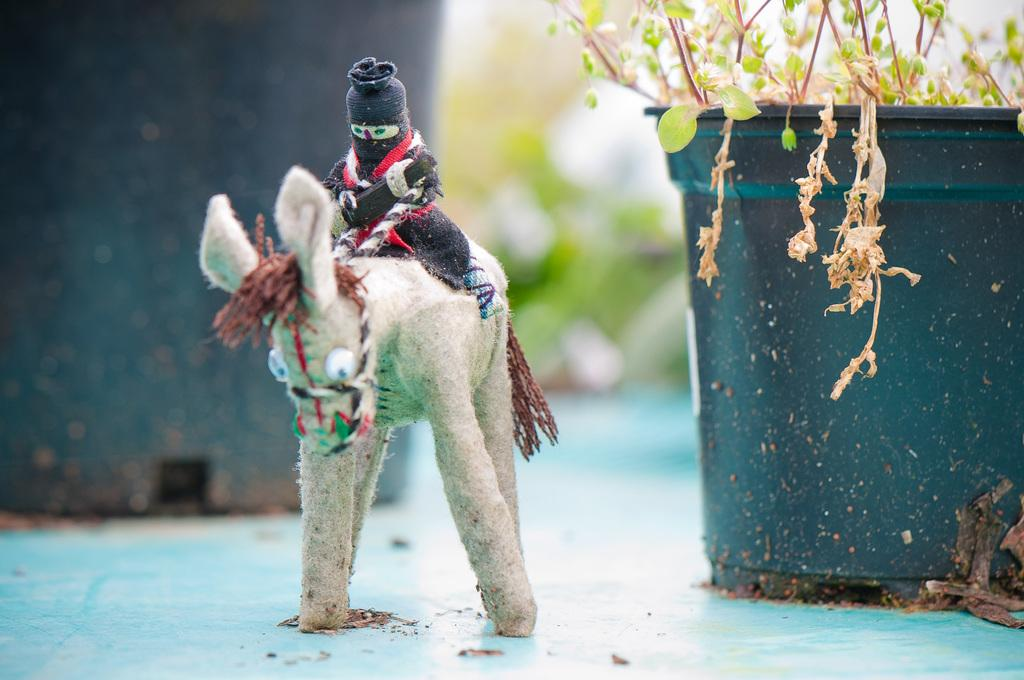What object can be seen in the image? There is a toy in the image. What colors are present on the toy? The toy is in cream and black color. What can be seen in the background of the image? There is a plant in the background of the image. What is the color of the plant? The plant is green. What is visible above the plant in the image? The sky is visible in the image. What is the color of the sky? The sky is white in color. Can you tell me how many beggars are present in the image? There are no beggars present in the image; it features a toy, a plant, and the sky. What type of bee can be seen buzzing around the toy in the image? There are no bees present in the image; it only features a toy, a plant, and the sky. 